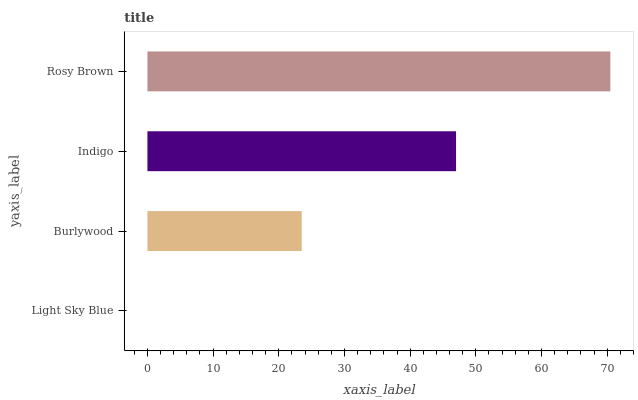Is Light Sky Blue the minimum?
Answer yes or no. Yes. Is Rosy Brown the maximum?
Answer yes or no. Yes. Is Burlywood the minimum?
Answer yes or no. No. Is Burlywood the maximum?
Answer yes or no. No. Is Burlywood greater than Light Sky Blue?
Answer yes or no. Yes. Is Light Sky Blue less than Burlywood?
Answer yes or no. Yes. Is Light Sky Blue greater than Burlywood?
Answer yes or no. No. Is Burlywood less than Light Sky Blue?
Answer yes or no. No. Is Indigo the high median?
Answer yes or no. Yes. Is Burlywood the low median?
Answer yes or no. Yes. Is Rosy Brown the high median?
Answer yes or no. No. Is Rosy Brown the low median?
Answer yes or no. No. 